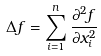Convert formula to latex. <formula><loc_0><loc_0><loc_500><loc_500>\Delta f = \sum _ { i = 1 } ^ { n } \frac { \partial ^ { 2 } f } { \partial x _ { i } ^ { 2 } }</formula> 